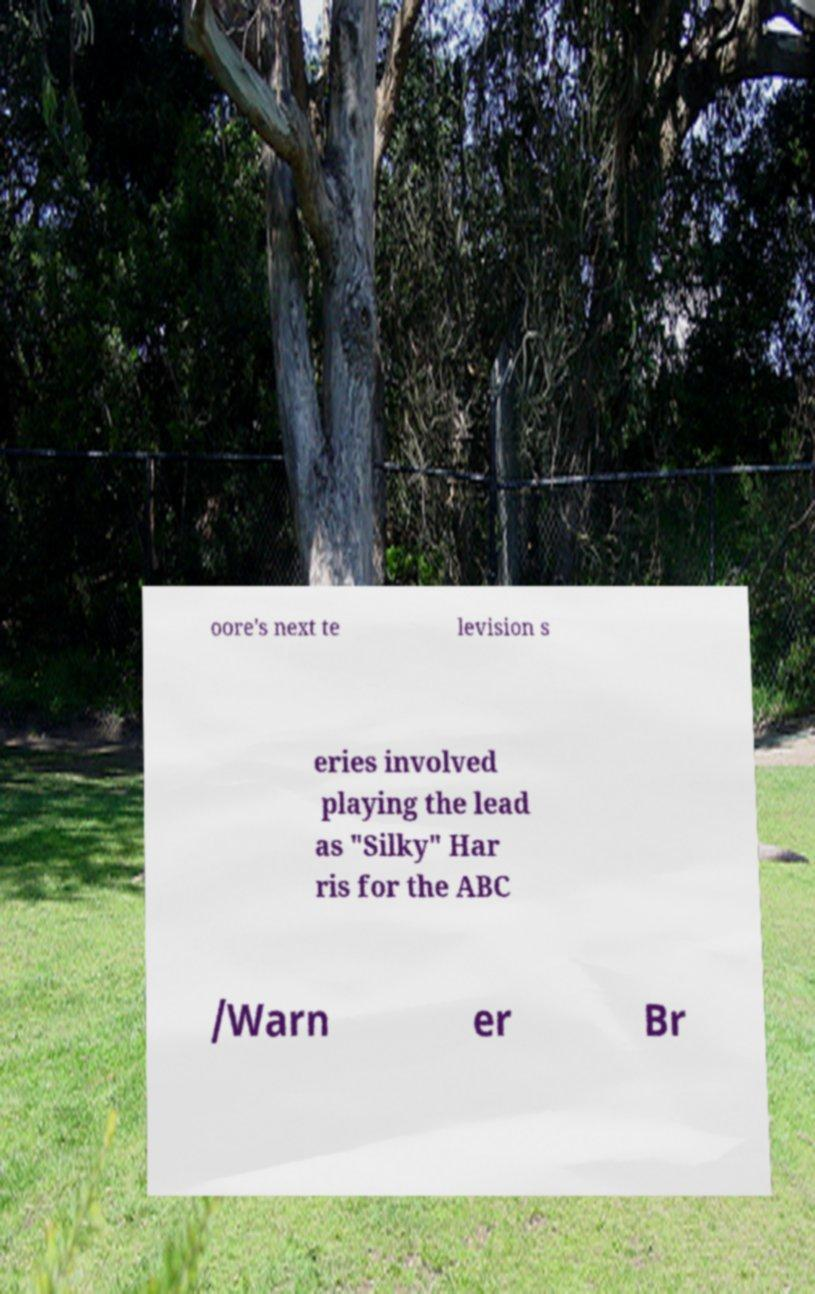Please read and relay the text visible in this image. What does it say? oore's next te levision s eries involved playing the lead as "Silky" Har ris for the ABC /Warn er Br 